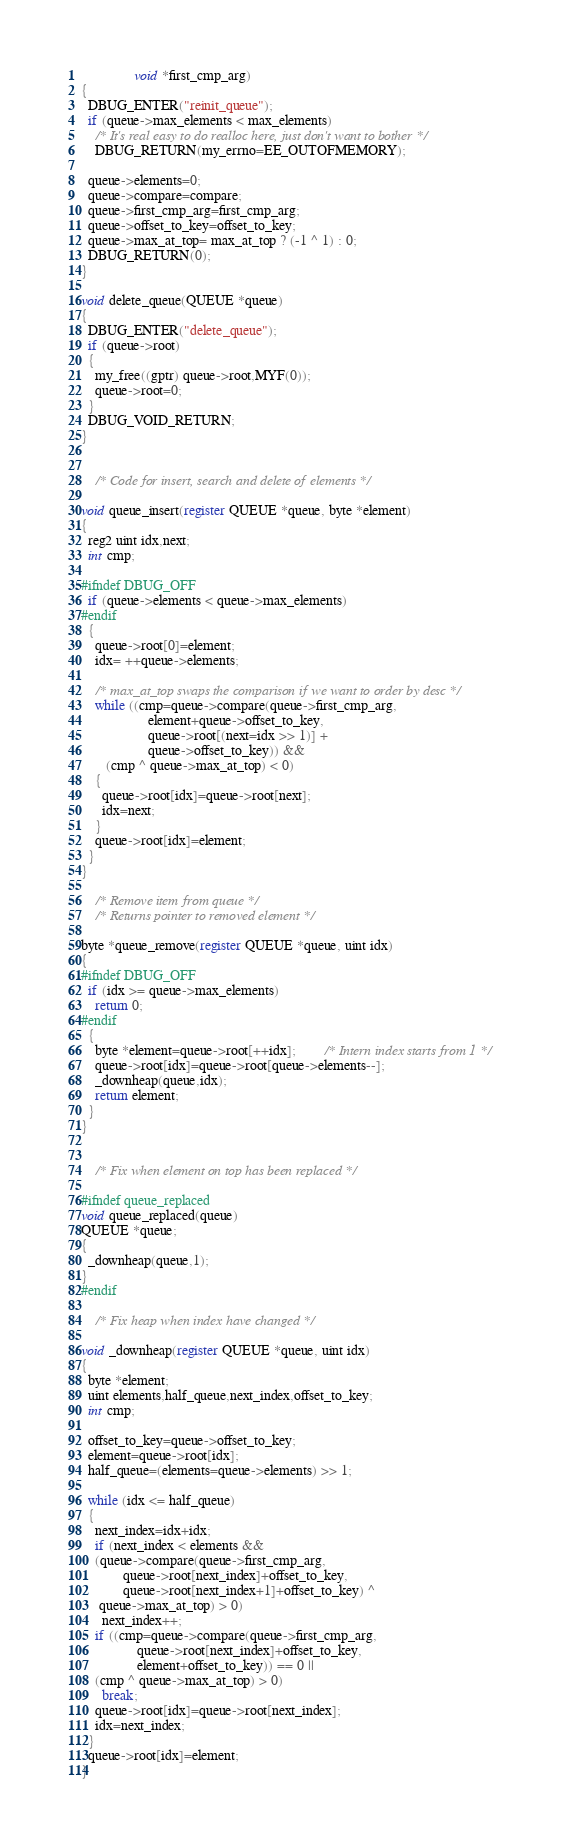<code> <loc_0><loc_0><loc_500><loc_500><_C_>               void *first_cmp_arg)
{
  DBUG_ENTER("reinit_queue");
  if (queue->max_elements < max_elements)
    /* It's real easy to do realloc here, just don't want to bother */
    DBUG_RETURN(my_errno=EE_OUTOFMEMORY);

  queue->elements=0;
  queue->compare=compare;
  queue->first_cmp_arg=first_cmp_arg;
  queue->offset_to_key=offset_to_key;
  queue->max_at_top= max_at_top ? (-1 ^ 1) : 0;
  DBUG_RETURN(0);
}

void delete_queue(QUEUE *queue)
{
  DBUG_ENTER("delete_queue");
  if (queue->root)
  {
    my_free((gptr) queue->root,MYF(0));
    queue->root=0;
  }
  DBUG_VOID_RETURN;
}


	/* Code for insert, search and delete of elements */

void queue_insert(register QUEUE *queue, byte *element)
{
  reg2 uint idx,next;
  int cmp;

#ifndef DBUG_OFF
  if (queue->elements < queue->max_elements)
#endif
  {
    queue->root[0]=element;
    idx= ++queue->elements;

    /* max_at_top swaps the comparison if we want to order by desc */
    while ((cmp=queue->compare(queue->first_cmp_arg,
			       element+queue->offset_to_key,
			       queue->root[(next=idx >> 1)] +
			       queue->offset_to_key)) &&
	   (cmp ^ queue->max_at_top) < 0)
    {
      queue->root[idx]=queue->root[next];
      idx=next;
    }
    queue->root[idx]=element;
  }
}

	/* Remove item from queue */
	/* Returns pointer to removed element */

byte *queue_remove(register QUEUE *queue, uint idx)
{
#ifndef DBUG_OFF
  if (idx >= queue->max_elements)
    return 0;
#endif
  {
    byte *element=queue->root[++idx];		/* Intern index starts from 1 */
    queue->root[idx]=queue->root[queue->elements--];
    _downheap(queue,idx);
    return element;
  }
}


	/* Fix when element on top has been replaced */

#ifndef queue_replaced
void queue_replaced(queue)
QUEUE *queue;
{
  _downheap(queue,1);
}
#endif

	/* Fix heap when index have changed */

void _downheap(register QUEUE *queue, uint idx)
{
  byte *element;
  uint elements,half_queue,next_index,offset_to_key;
  int cmp;

  offset_to_key=queue->offset_to_key;
  element=queue->root[idx];
  half_queue=(elements=queue->elements) >> 1;

  while (idx <= half_queue)
  {
    next_index=idx+idx;
    if (next_index < elements &&
	(queue->compare(queue->first_cmp_arg,
			queue->root[next_index]+offset_to_key,
			queue->root[next_index+1]+offset_to_key) ^
	 queue->max_at_top) > 0)
      next_index++;
    if ((cmp=queue->compare(queue->first_cmp_arg,
			    queue->root[next_index]+offset_to_key,
			    element+offset_to_key)) == 0 ||
	(cmp ^ queue->max_at_top) > 0)
      break;
    queue->root[idx]=queue->root[next_index];
    idx=next_index;
  }
  queue->root[idx]=element;
}
</code> 